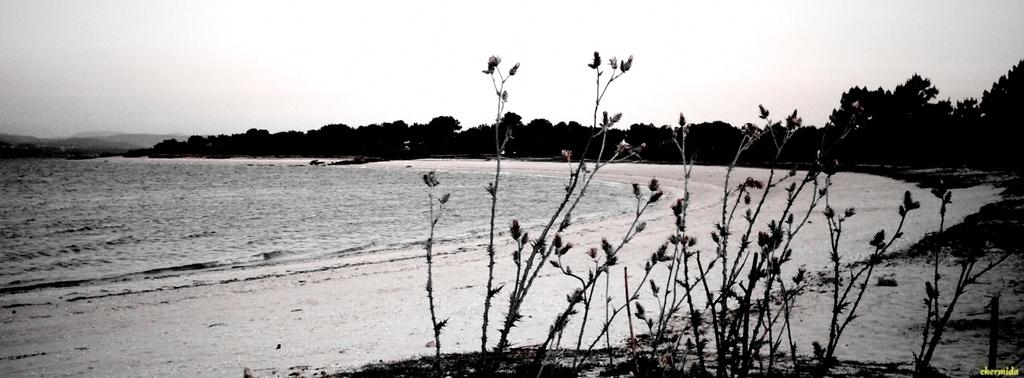What type of vegetation can be seen on the right side of the image? There are plants on the right side of the image. What is located in the center of the image? There is water in the center of the image. What can be seen in the background of the image? The sky, clouds, trees, and water are visible in the background of the image. What type of toy is being pointed at by the partner in the image? There is no partner or toy present in the image. What color is the point on the toy in the image? There is no point or toy present in the image. 